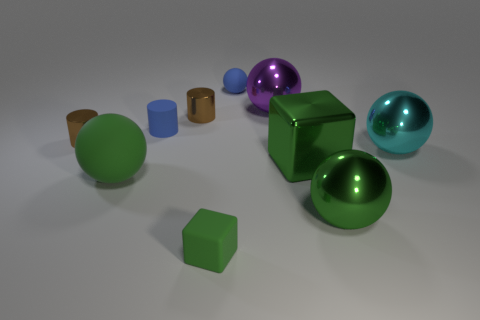Subtract all large green balls. How many balls are left? 3 Subtract 4 balls. How many balls are left? 1 Subtract all blue cylinders. How many cylinders are left? 2 Subtract all cylinders. How many objects are left? 7 Subtract all yellow spheres. How many brown cylinders are left? 2 Subtract all big green rubber things. Subtract all blue spheres. How many objects are left? 8 Add 4 blue rubber balls. How many blue rubber balls are left? 5 Add 9 tiny green matte cylinders. How many tiny green matte cylinders exist? 9 Subtract 0 red balls. How many objects are left? 10 Subtract all purple cylinders. Subtract all red blocks. How many cylinders are left? 3 